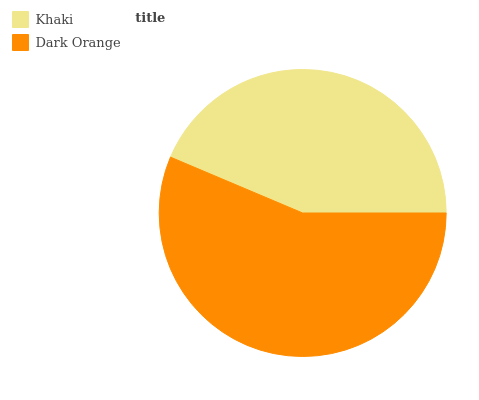Is Khaki the minimum?
Answer yes or no. Yes. Is Dark Orange the maximum?
Answer yes or no. Yes. Is Dark Orange the minimum?
Answer yes or no. No. Is Dark Orange greater than Khaki?
Answer yes or no. Yes. Is Khaki less than Dark Orange?
Answer yes or no. Yes. Is Khaki greater than Dark Orange?
Answer yes or no. No. Is Dark Orange less than Khaki?
Answer yes or no. No. Is Dark Orange the high median?
Answer yes or no. Yes. Is Khaki the low median?
Answer yes or no. Yes. Is Khaki the high median?
Answer yes or no. No. Is Dark Orange the low median?
Answer yes or no. No. 